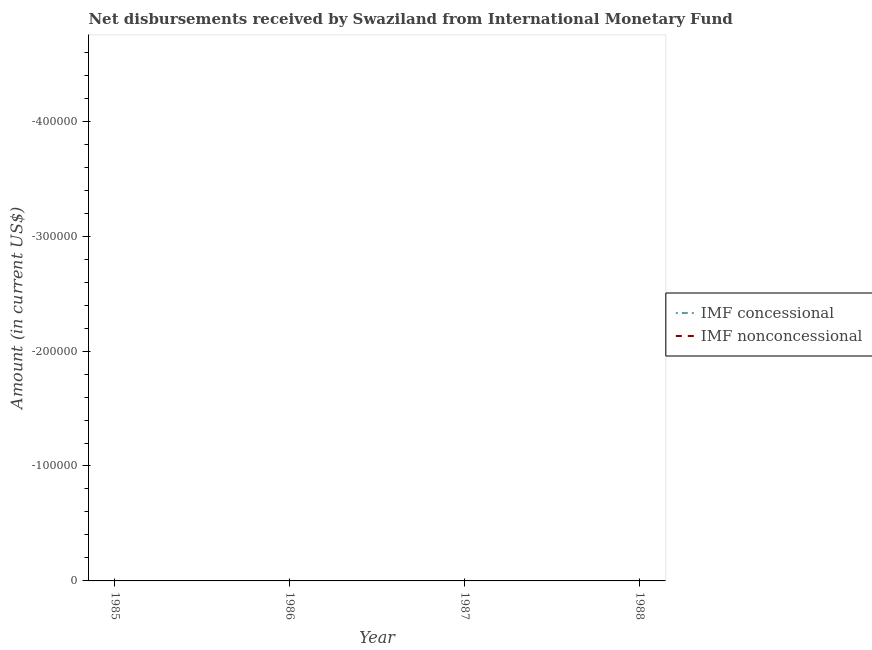How many different coloured lines are there?
Ensure brevity in your answer.  0. What is the net non concessional disbursements from imf in 1988?
Keep it short and to the point. 0. Across all years, what is the minimum net concessional disbursements from imf?
Offer a terse response. 0. What is the average net concessional disbursements from imf per year?
Your response must be concise. 0. In how many years, is the net concessional disbursements from imf greater than the average net concessional disbursements from imf taken over all years?
Provide a short and direct response. 0. Does the net non concessional disbursements from imf monotonically increase over the years?
Your answer should be very brief. No. Is the net concessional disbursements from imf strictly less than the net non concessional disbursements from imf over the years?
Your response must be concise. No. What is the difference between two consecutive major ticks on the Y-axis?
Ensure brevity in your answer.  1.00e+05. Are the values on the major ticks of Y-axis written in scientific E-notation?
Offer a very short reply. No. Where does the legend appear in the graph?
Keep it short and to the point. Center right. How many legend labels are there?
Your response must be concise. 2. How are the legend labels stacked?
Your answer should be compact. Vertical. What is the title of the graph?
Your response must be concise. Net disbursements received by Swaziland from International Monetary Fund. Does "Crop" appear as one of the legend labels in the graph?
Offer a very short reply. No. What is the label or title of the X-axis?
Keep it short and to the point. Year. What is the Amount (in current US$) of IMF nonconcessional in 1985?
Ensure brevity in your answer.  0. What is the Amount (in current US$) of IMF nonconcessional in 1986?
Your answer should be very brief. 0. What is the Amount (in current US$) of IMF concessional in 1987?
Provide a short and direct response. 0. What is the Amount (in current US$) in IMF concessional in 1988?
Make the answer very short. 0. What is the total Amount (in current US$) of IMF concessional in the graph?
Offer a very short reply. 0. What is the average Amount (in current US$) of IMF concessional per year?
Make the answer very short. 0. What is the average Amount (in current US$) of IMF nonconcessional per year?
Keep it short and to the point. 0. 